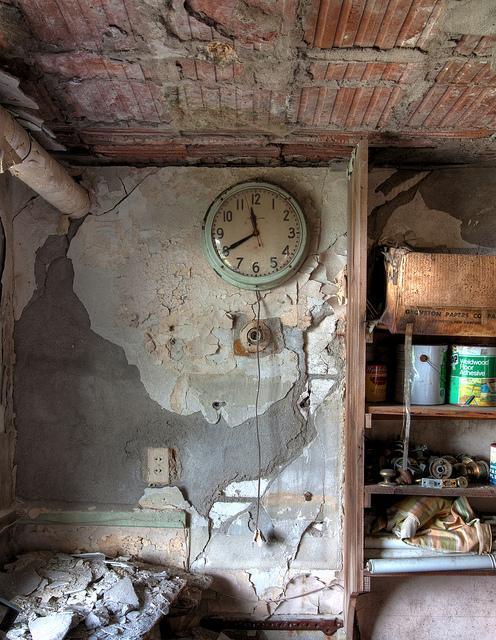How many people are riding horses?
Give a very brief answer. 0. 